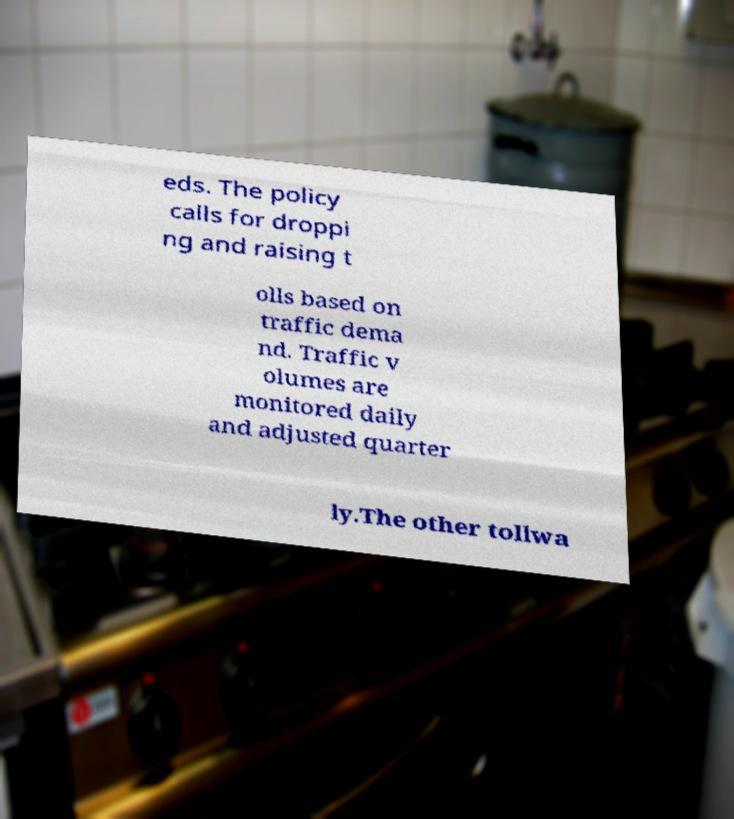I need the written content from this picture converted into text. Can you do that? eds. The policy calls for droppi ng and raising t olls based on traffic dema nd. Traffic v olumes are monitored daily and adjusted quarter ly.The other tollwa 